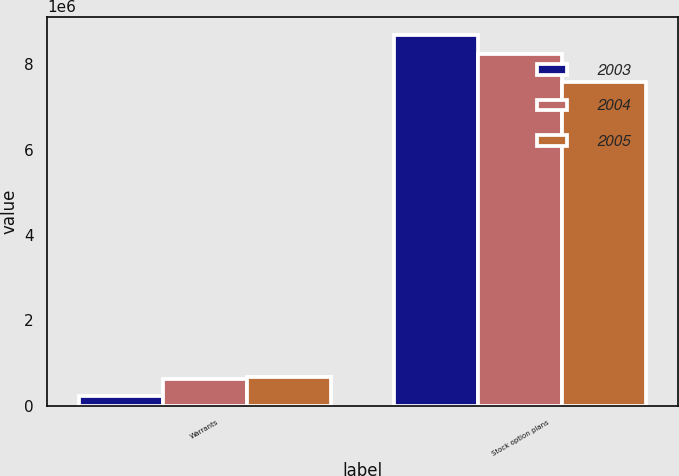Convert chart. <chart><loc_0><loc_0><loc_500><loc_500><stacked_bar_chart><ecel><fcel>Warrants<fcel>Stock option plans<nl><fcel>2003<fcel>238703<fcel>8.68425e+06<nl><fcel>2004<fcel>637151<fcel>8.23412e+06<nl><fcel>2005<fcel>662256<fcel>7.58372e+06<nl></chart> 